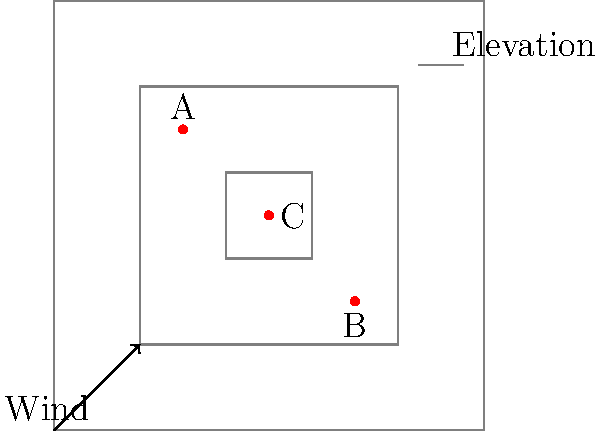Given the topographical map showing three wind turbines (A, B, and C) and wind direction, which turbine placement is likely to be the least efficient for energy production? To determine the least efficient wind turbine placement, we need to consider the following factors:

1. Elevation: Higher elevations generally have stronger and more consistent winds.
2. Wind direction: Turbines should be positioned to capture the prevailing wind.
3. Interference: Turbines should not be in the wake of other turbines or obstacles.

Analyzing each turbine:

1. Turbine A (30,70):
   - Located at a relatively high elevation (second contour)
   - Positioned well to capture the prevailing wind
   - No interference from other turbines

2. Turbine B (70,30):
   - Located at a relatively high elevation (second contour)
   - Positioned well to capture the prevailing wind
   - No interference from other turbines

3. Turbine C (50,50):
   - Located at the highest elevation (third contour)
   - Positioned in the wake of Turbines A and B
   - May experience reduced wind speed due to interference

Although Turbine C is at the highest elevation, its position in the wake of Turbines A and B is likely to significantly reduce its efficiency. The wind reaching Turbine C will have less energy due to the extraction by the upwind turbines.

Therefore, Turbine C is likely to be the least efficient for energy production in this configuration.
Answer: Turbine C 